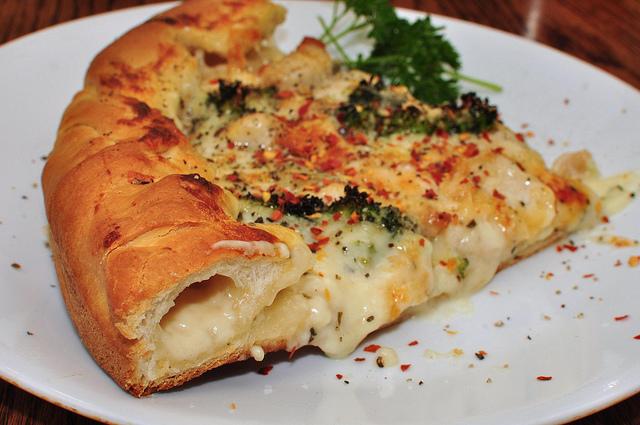Is the pizza thin crust?
Answer briefly. No. Is the pizza fat free?
Give a very brief answer. No. Is this a hot dog?
Short answer required. No. Is that a stuffed crust?
Answer briefly. Yes. What is this food?
Answer briefly. Pizza. Is this a cut in half burrito?
Write a very short answer. No. 